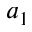<formula> <loc_0><loc_0><loc_500><loc_500>a _ { 1 }</formula> 